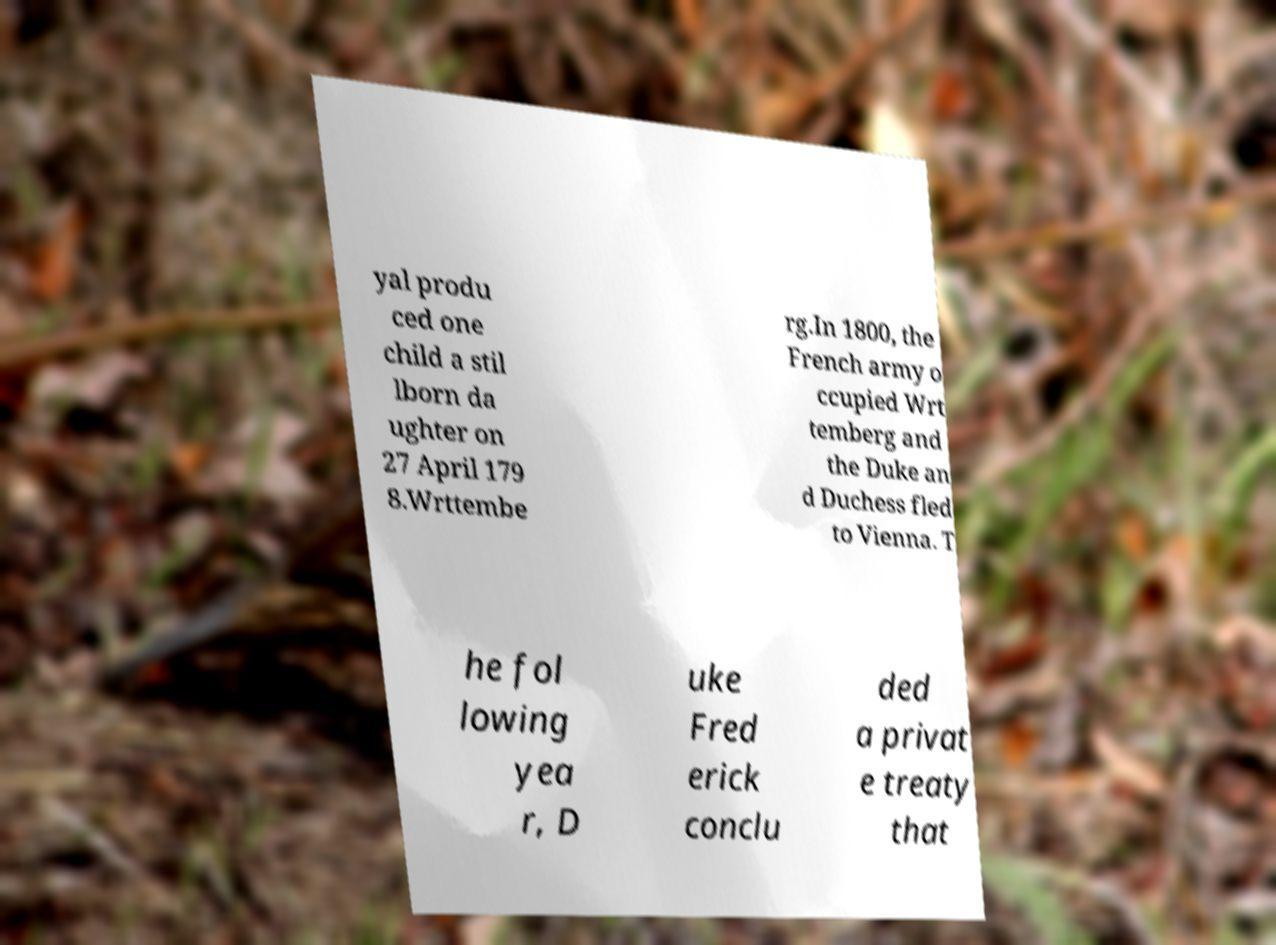What messages or text are displayed in this image? I need them in a readable, typed format. yal produ ced one child a stil lborn da ughter on 27 April 179 8.Wrttembe rg.In 1800, the French army o ccupied Wrt temberg and the Duke an d Duchess fled to Vienna. T he fol lowing yea r, D uke Fred erick conclu ded a privat e treaty that 